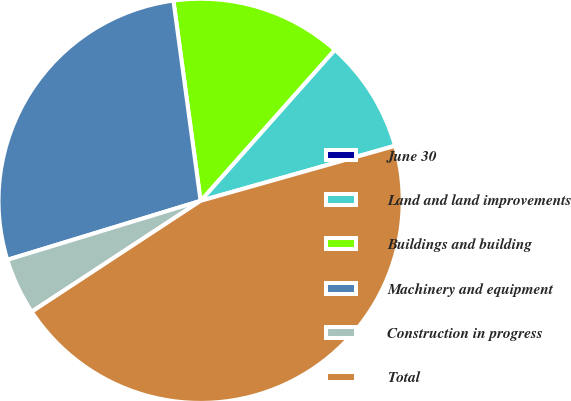Convert chart. <chart><loc_0><loc_0><loc_500><loc_500><pie_chart><fcel>June 30<fcel>Land and land improvements<fcel>Buildings and building<fcel>Machinery and equipment<fcel>Construction in progress<fcel>Total<nl><fcel>0.02%<fcel>9.04%<fcel>13.71%<fcel>27.57%<fcel>4.53%<fcel>45.14%<nl></chart> 